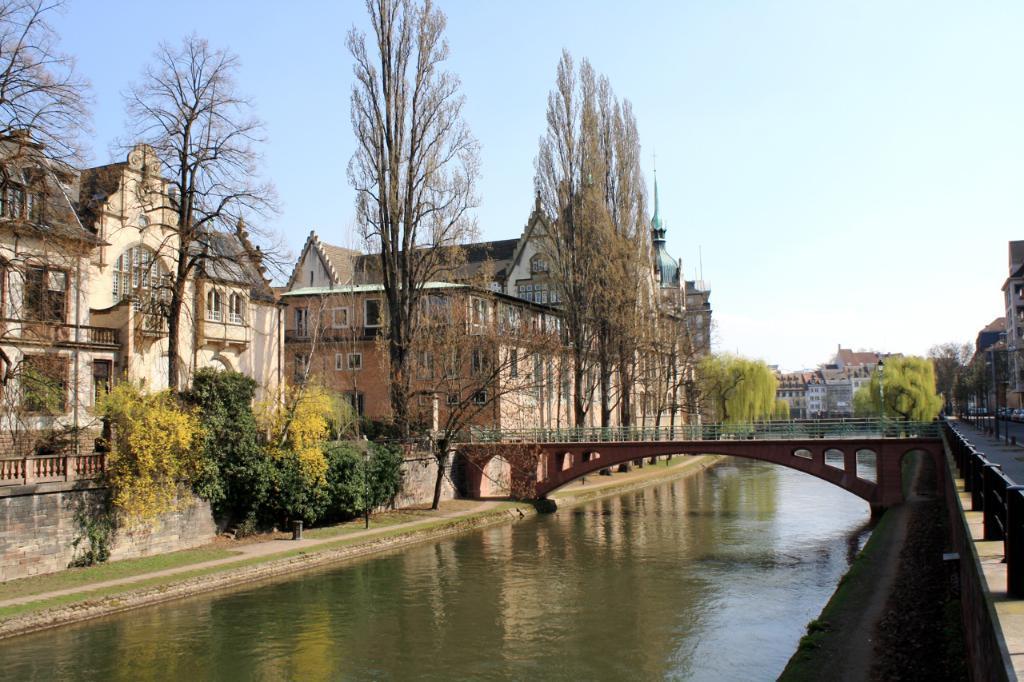Please provide a concise description of this image. In this picture we can see the water. Some grass is visible on the ground. We can see a few plants, poles, a bridge and some fencing on the right side. There are a few trees and houses in the background. We can see the sky on top of the picture. 